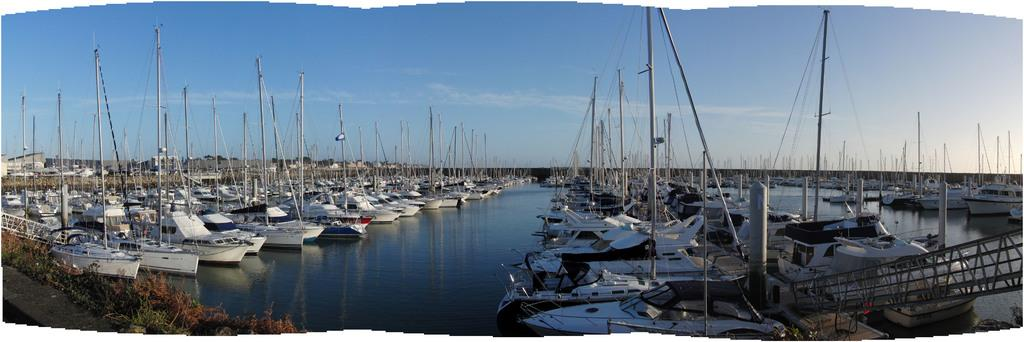What is located above the water in the image? There are boats above the water in the image. What objects are visible in the image that are used for support or guidance? Poles are visible in the image. What type of material is present in the image that is used for tying or securing objects? Rope is present in the image. What can be seen in the background of the image? The sky is visible in the background of the image. How many sisters are playing with the ball on the beds in the image? There are no sisters, balls, or beds present in the image. 